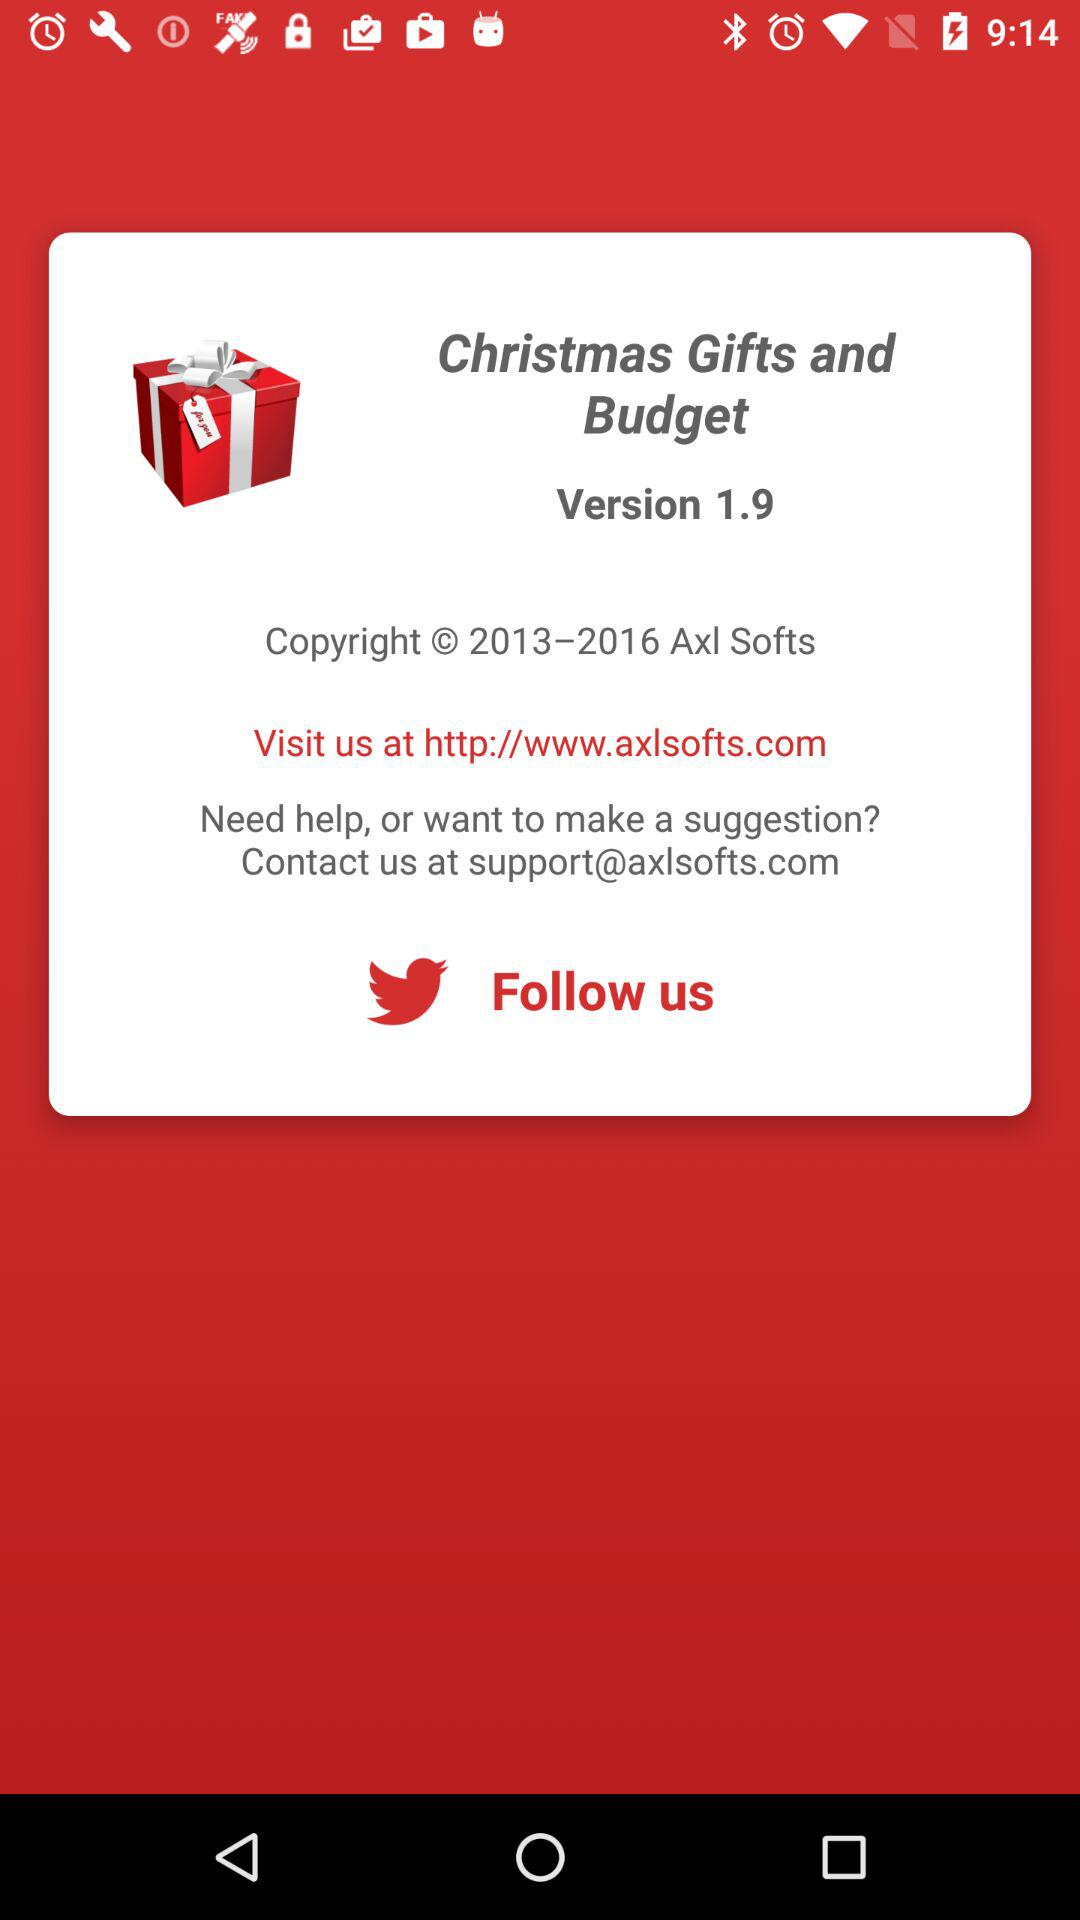What is the website of the company? The website of the company is http://www.axlsofts.com. 